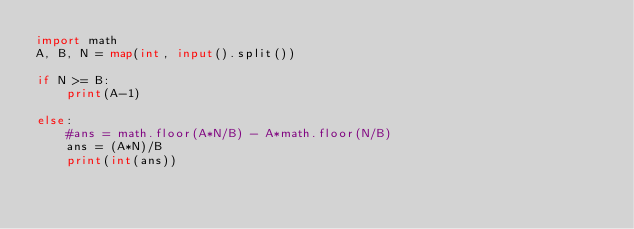<code> <loc_0><loc_0><loc_500><loc_500><_Python_>import math
A, B, N = map(int, input().split())

if N >= B:
    print(A-1)

else:
    #ans = math.floor(A*N/B) - A*math.floor(N/B)
    ans = (A*N)/B
    print(int(ans))
</code> 